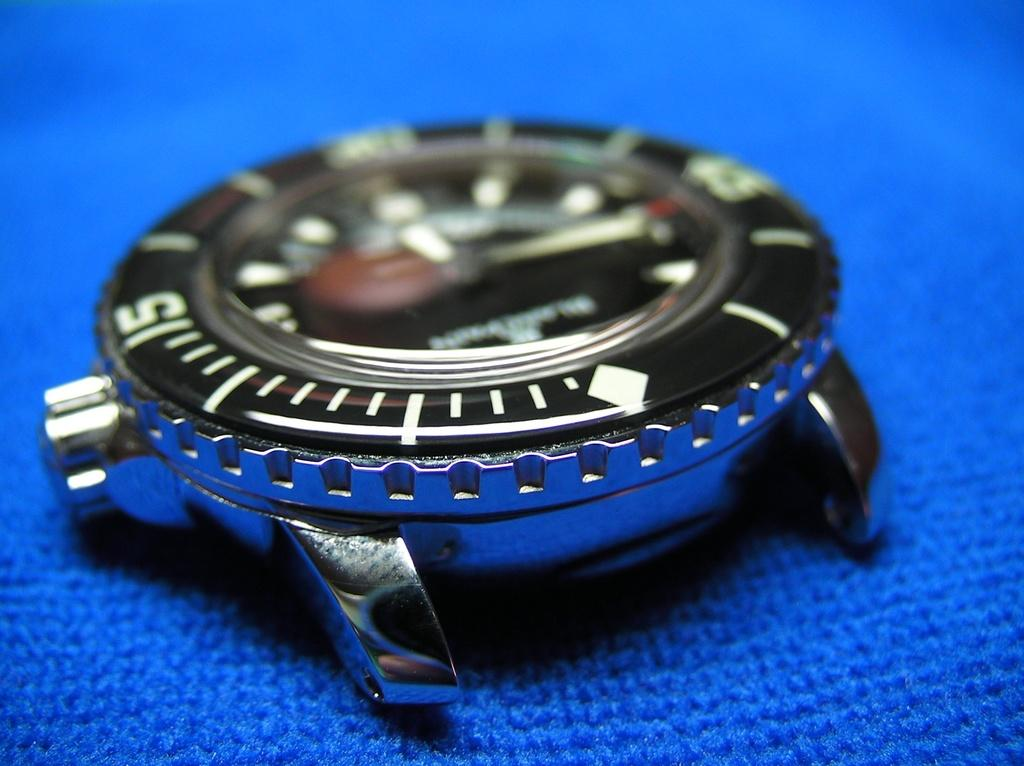Provide a one-sentence caption for the provided image. A somewhat blurry number 5 is visible on a watch face. 